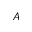Convert formula to latex. <formula><loc_0><loc_0><loc_500><loc_500>A</formula> 